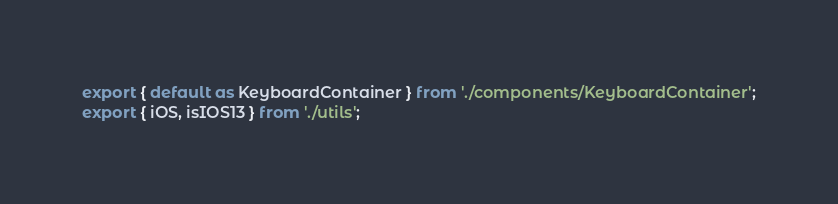<code> <loc_0><loc_0><loc_500><loc_500><_TypeScript_>export { default as KeyboardContainer } from './components/KeyboardContainer';
export { iOS, isIOS13 } from './utils';
</code> 